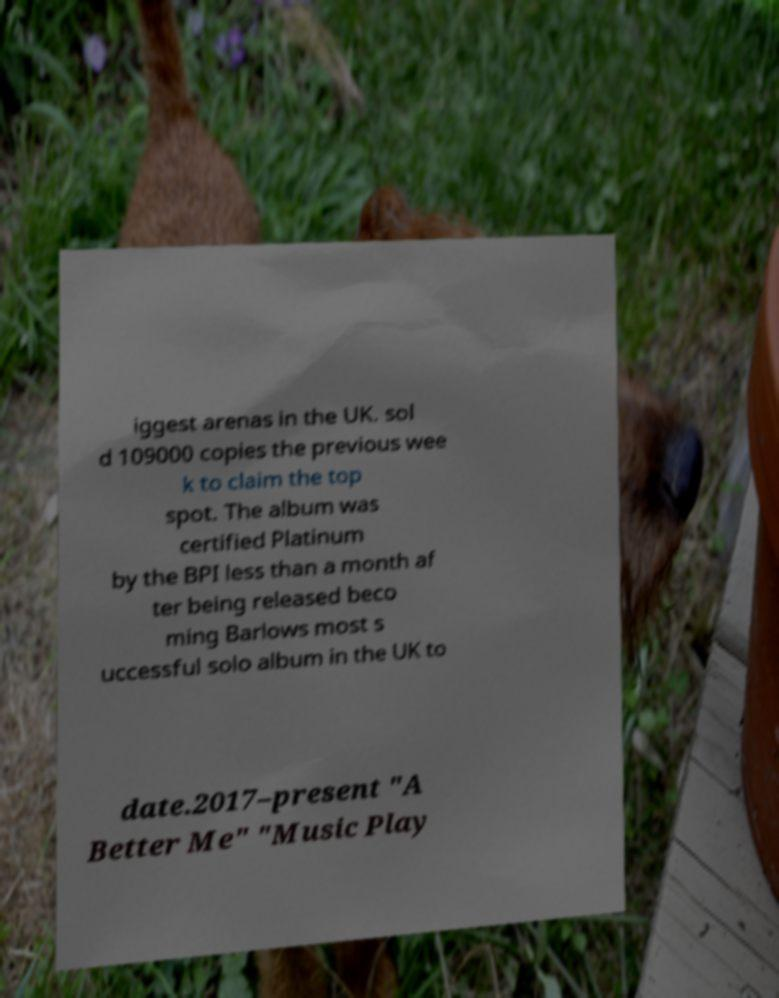I need the written content from this picture converted into text. Can you do that? iggest arenas in the UK. sol d 109000 copies the previous wee k to claim the top spot. The album was certified Platinum by the BPI less than a month af ter being released beco ming Barlows most s uccessful solo album in the UK to date.2017–present "A Better Me" "Music Play 